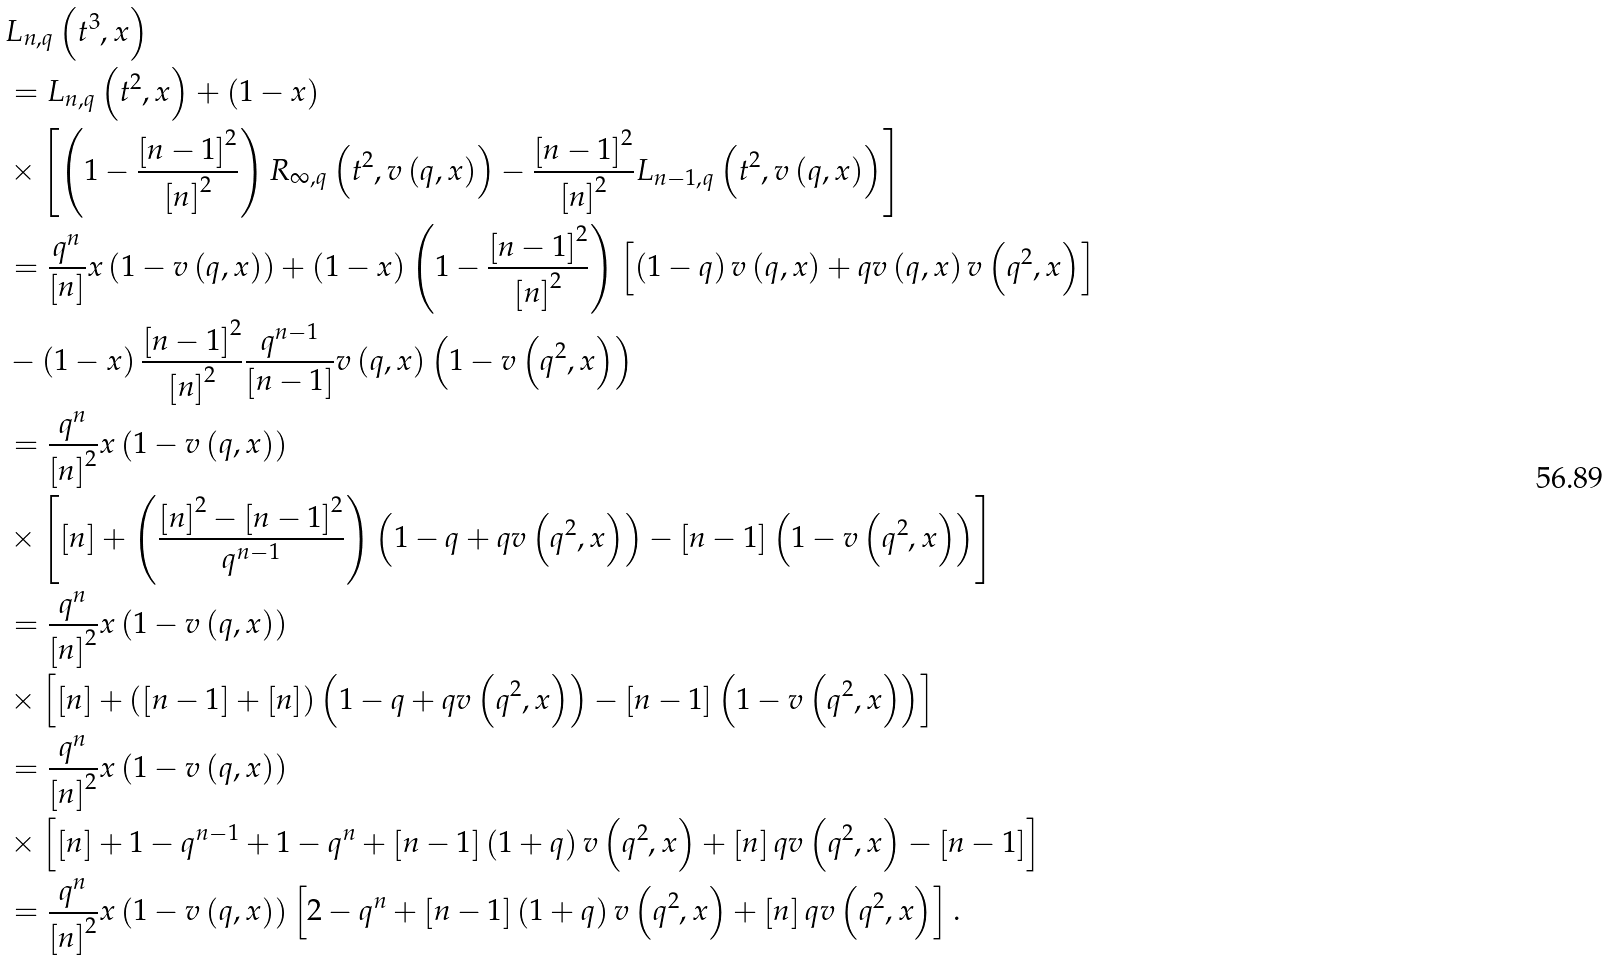Convert formula to latex. <formula><loc_0><loc_0><loc_500><loc_500>& L _ { n , q } \left ( t ^ { 3 } , x \right ) \\ & = L _ { n , q } \left ( t ^ { 2 } , x \right ) + \left ( 1 - x \right ) \\ & \times \left [ \left ( 1 - \frac { \left [ n - 1 \right ] ^ { 2 } } { \left [ n \right ] ^ { 2 } } \right ) R _ { \infty , q } \left ( t ^ { 2 } , v \left ( q , x \right ) \right ) - \frac { \left [ n - 1 \right ] ^ { 2 } } { \left [ n \right ] ^ { 2 } } L _ { n - 1 , q } \left ( t ^ { 2 } , v \left ( q , x \right ) \right ) \right ] \\ & = \frac { q ^ { n } } { \left [ n \right ] } x \left ( 1 - v \left ( q , x \right ) \right ) + \left ( 1 - x \right ) \left ( 1 - \frac { \left [ n - 1 \right ] ^ { 2 } } { \left [ n \right ] ^ { 2 } } \right ) \left [ \left ( 1 - q \right ) v \left ( q , x \right ) + q v \left ( q , x \right ) v \left ( q ^ { 2 } , x \right ) \right ] \\ & - \left ( 1 - x \right ) \frac { \left [ n - 1 \right ] ^ { 2 } } { \left [ n \right ] ^ { 2 } } \frac { q ^ { n - 1 } } { \left [ n - 1 \right ] } v \left ( q , x \right ) \left ( 1 - v \left ( q ^ { 2 } , x \right ) \right ) \\ & = \frac { q ^ { n } } { \left [ n \right ] ^ { 2 } } x \left ( 1 - v \left ( q , x \right ) \right ) \\ & \times \left [ \left [ n \right ] + \left ( \frac { \left [ n \right ] ^ { 2 } - \left [ n - 1 \right ] ^ { 2 } } { q ^ { n - 1 } } \right ) \left ( 1 - q + q v \left ( q ^ { 2 } , x \right ) \right ) - \left [ n - 1 \right ] \left ( 1 - v \left ( q ^ { 2 } , x \right ) \right ) \right ] \\ & = \frac { q ^ { n } } { \left [ n \right ] ^ { 2 } } x \left ( 1 - v \left ( q , x \right ) \right ) \\ & \times \left [ \left [ n \right ] + \left ( \left [ n - 1 \right ] + \left [ n \right ] \right ) \left ( 1 - q + q v \left ( q ^ { 2 } , x \right ) \right ) - \left [ n - 1 \right ] \left ( 1 - v \left ( q ^ { 2 } , x \right ) \right ) \right ] \\ & = \frac { q ^ { n } } { \left [ n \right ] ^ { 2 } } x \left ( 1 - v \left ( q , x \right ) \right ) \\ & \times \left [ \left [ n \right ] + 1 - q ^ { n - 1 } + 1 - q ^ { n } + \left [ n - 1 \right ] \left ( 1 + q \right ) v \left ( q ^ { 2 } , x \right ) + \left [ n \right ] q v \left ( q ^ { 2 } , x \right ) - \left [ n - 1 \right ] \right ] \\ & = \frac { q ^ { n } } { \left [ n \right ] ^ { 2 } } x \left ( 1 - v \left ( q , x \right ) \right ) \left [ 2 - q ^ { n } + \left [ n - 1 \right ] \left ( 1 + q \right ) v \left ( q ^ { 2 } , x \right ) + \left [ n \right ] q v \left ( q ^ { 2 } , x \right ) \right ] .</formula> 